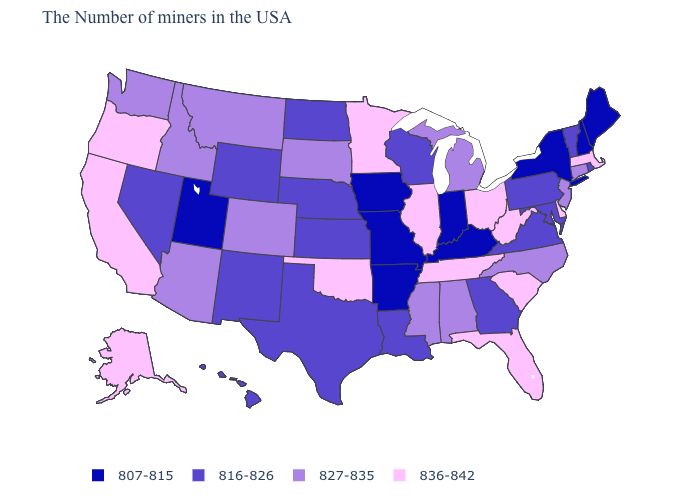What is the value of South Dakota?
Write a very short answer. 827-835. What is the highest value in states that border West Virginia?
Be succinct. 836-842. What is the value of Missouri?
Quick response, please. 807-815. What is the value of Washington?
Quick response, please. 827-835. Which states have the highest value in the USA?
Write a very short answer. Massachusetts, Delaware, South Carolina, West Virginia, Ohio, Florida, Tennessee, Illinois, Minnesota, Oklahoma, California, Oregon, Alaska. Name the states that have a value in the range 816-826?
Write a very short answer. Rhode Island, Vermont, Maryland, Pennsylvania, Virginia, Georgia, Wisconsin, Louisiana, Kansas, Nebraska, Texas, North Dakota, Wyoming, New Mexico, Nevada, Hawaii. Does Connecticut have the same value as Kentucky?
Give a very brief answer. No. Does the first symbol in the legend represent the smallest category?
Be succinct. Yes. Name the states that have a value in the range 836-842?
Quick response, please. Massachusetts, Delaware, South Carolina, West Virginia, Ohio, Florida, Tennessee, Illinois, Minnesota, Oklahoma, California, Oregon, Alaska. Does Maryland have the highest value in the USA?
Keep it brief. No. What is the value of Georgia?
Keep it brief. 816-826. Does Arkansas have the lowest value in the USA?
Give a very brief answer. Yes. Does Texas have the same value as Nebraska?
Concise answer only. Yes. Name the states that have a value in the range 836-842?
Be succinct. Massachusetts, Delaware, South Carolina, West Virginia, Ohio, Florida, Tennessee, Illinois, Minnesota, Oklahoma, California, Oregon, Alaska. What is the lowest value in the West?
Concise answer only. 807-815. 